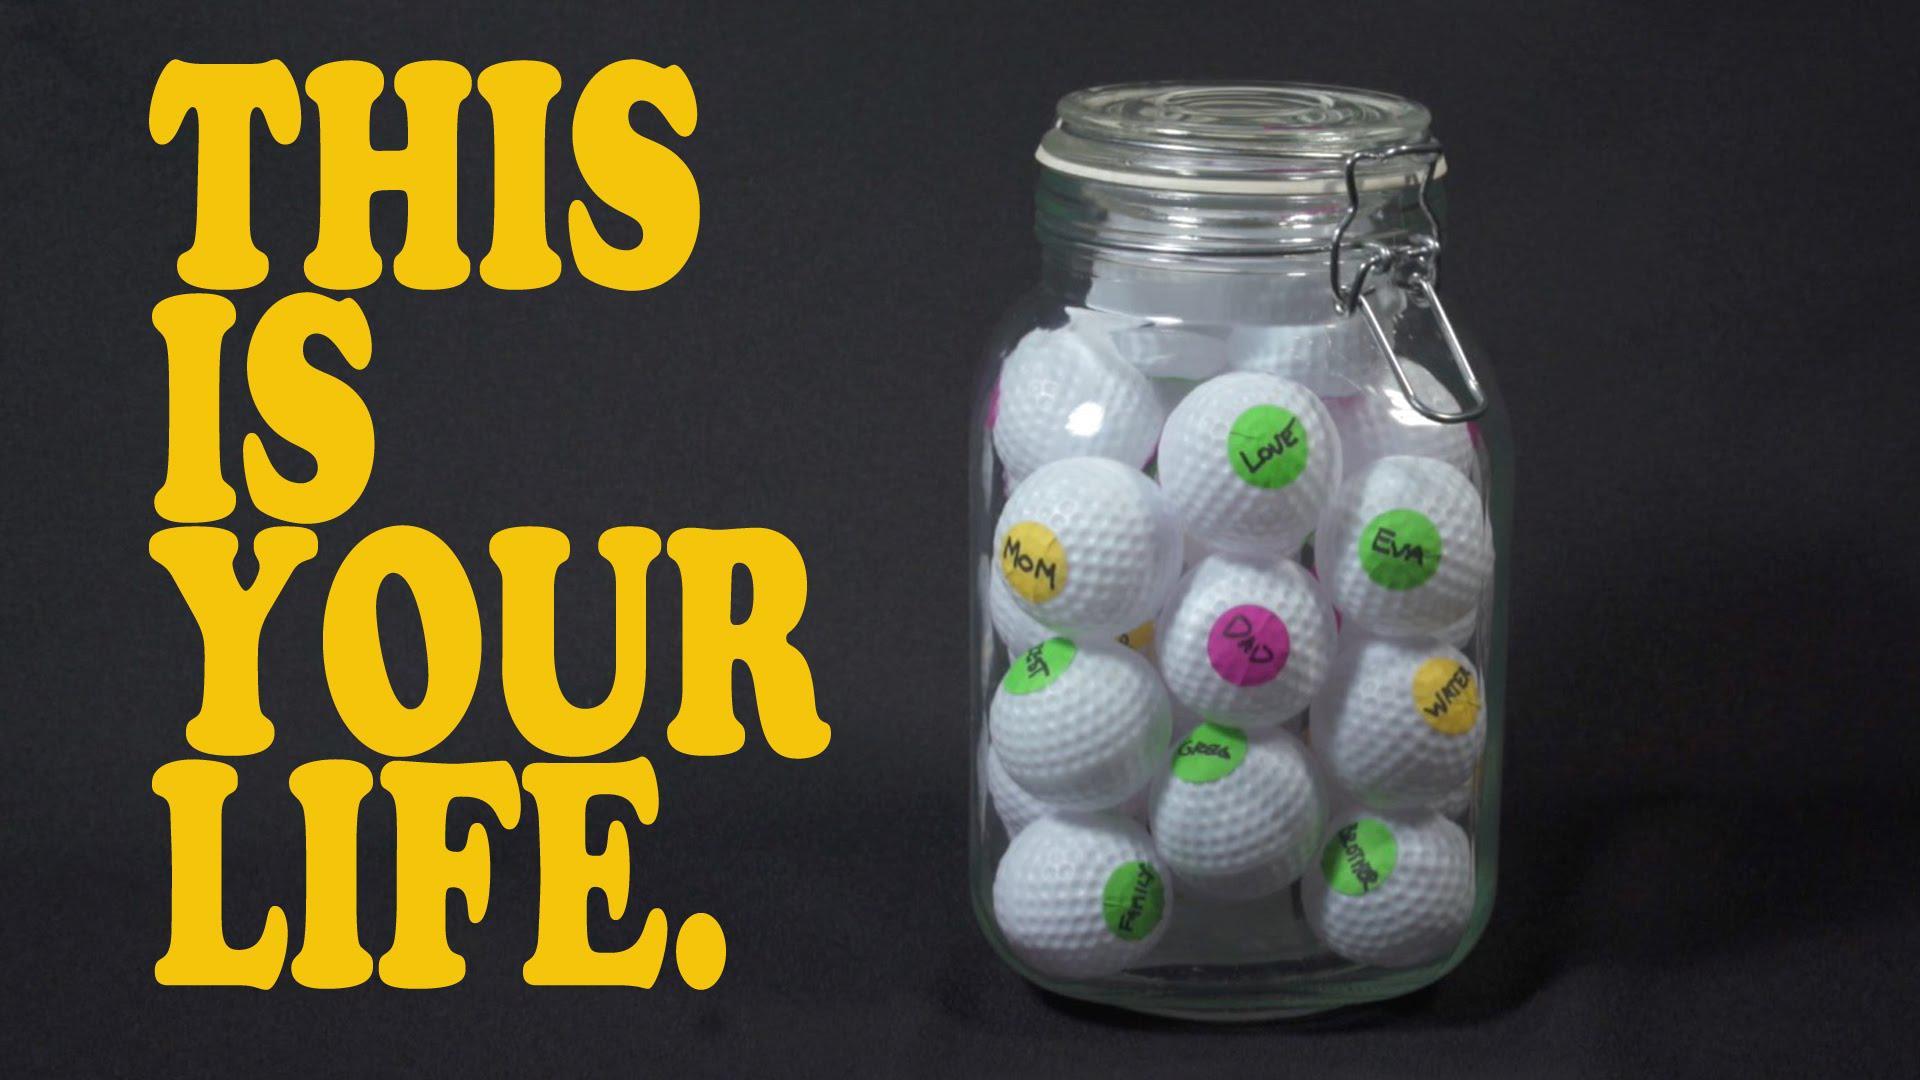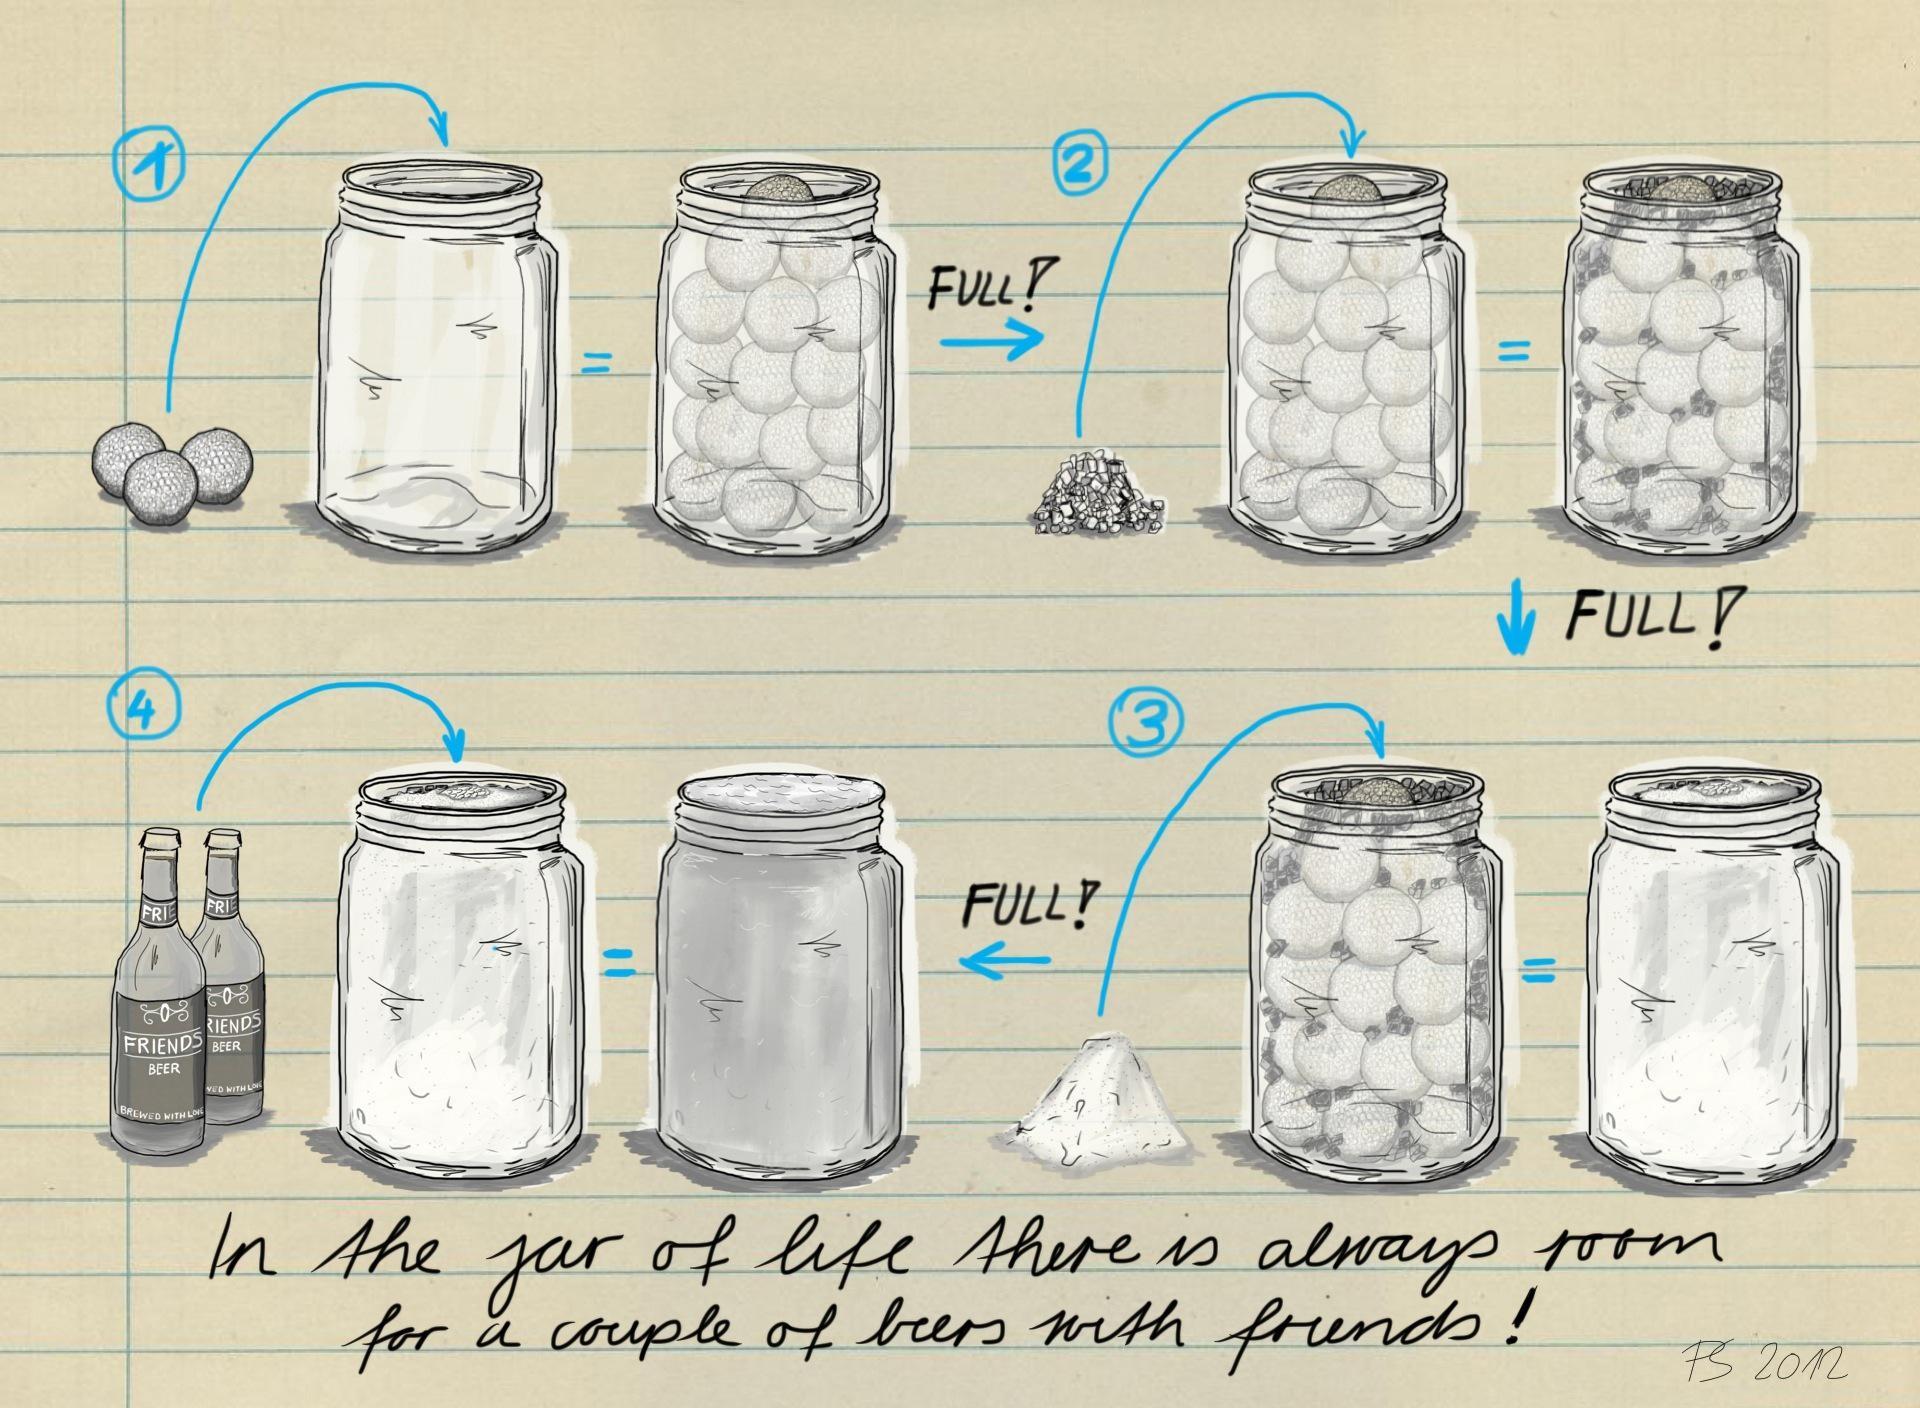The first image is the image on the left, the second image is the image on the right. Given the left and right images, does the statement "In at least one image there is at least one empty and full jar of golf balls." hold true? Answer yes or no. Yes. 